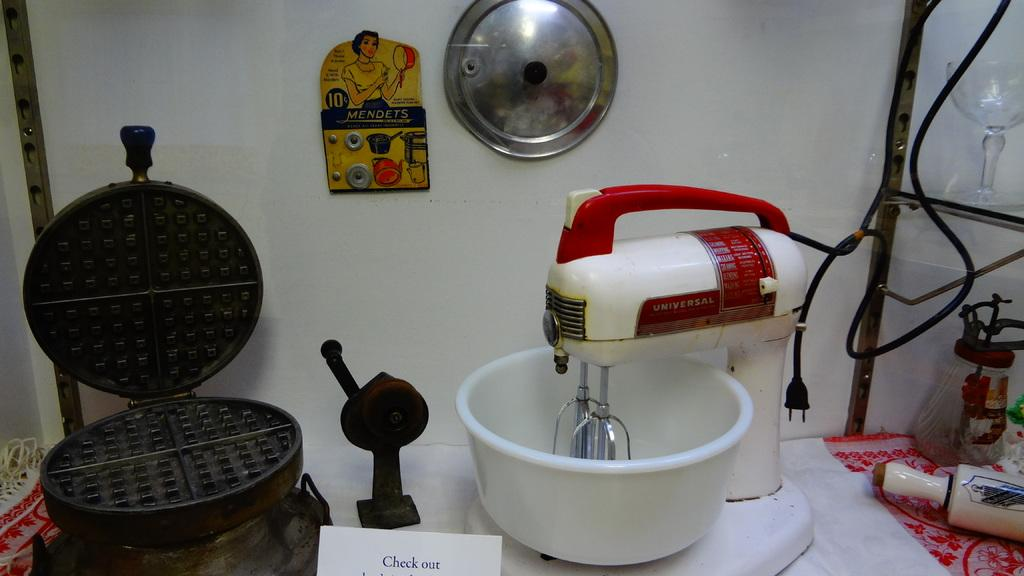<image>
Offer a succinct explanation of the picture presented. A waffle iron and electric mixer with a card that says check out in front of them. 